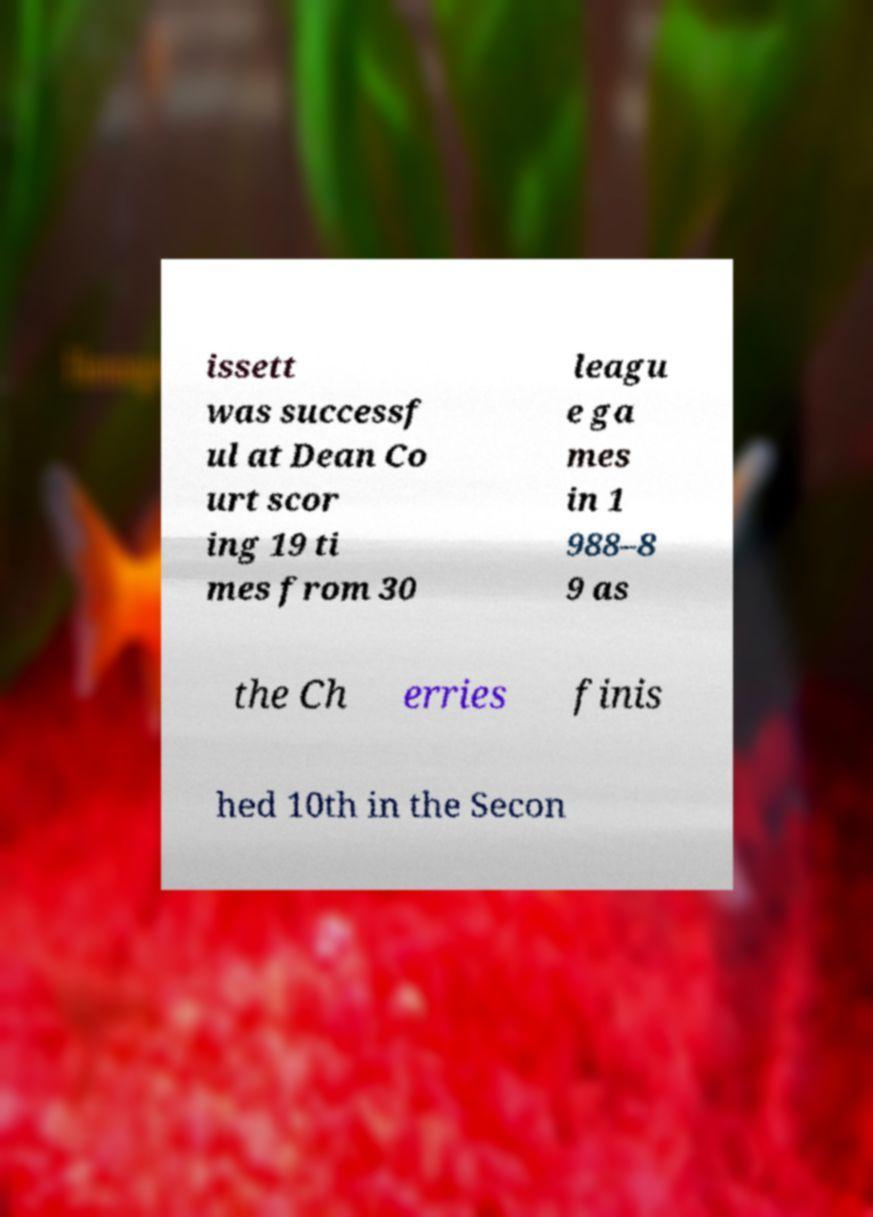Please identify and transcribe the text found in this image. issett was successf ul at Dean Co urt scor ing 19 ti mes from 30 leagu e ga mes in 1 988–8 9 as the Ch erries finis hed 10th in the Secon 